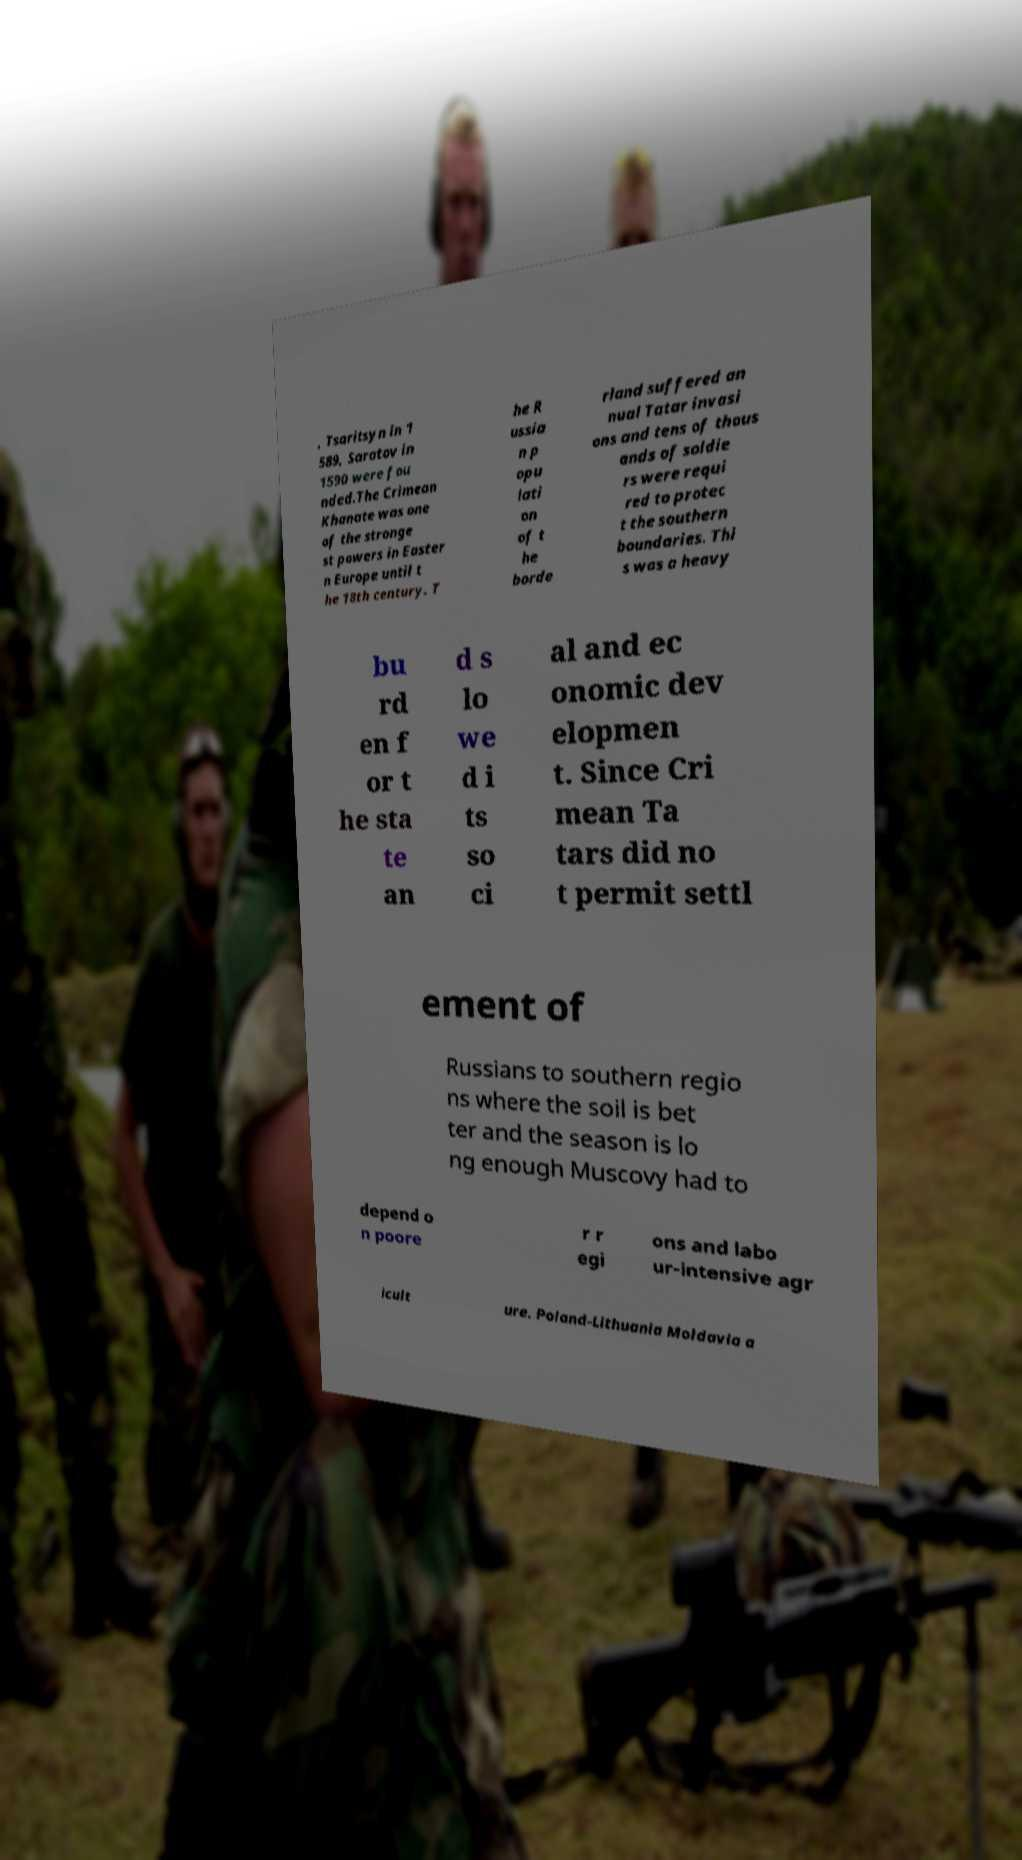Please identify and transcribe the text found in this image. , Tsaritsyn in 1 589, Saratov in 1590 were fou nded.The Crimean Khanate was one of the stronge st powers in Easter n Europe until t he 18th century. T he R ussia n p opu lati on of t he borde rland suffered an nual Tatar invasi ons and tens of thous ands of soldie rs were requi red to protec t the southern boundaries. Thi s was a heavy bu rd en f or t he sta te an d s lo we d i ts so ci al and ec onomic dev elopmen t. Since Cri mean Ta tars did no t permit settl ement of Russians to southern regio ns where the soil is bet ter and the season is lo ng enough Muscovy had to depend o n poore r r egi ons and labo ur-intensive agr icult ure. Poland-Lithuania Moldavia a 